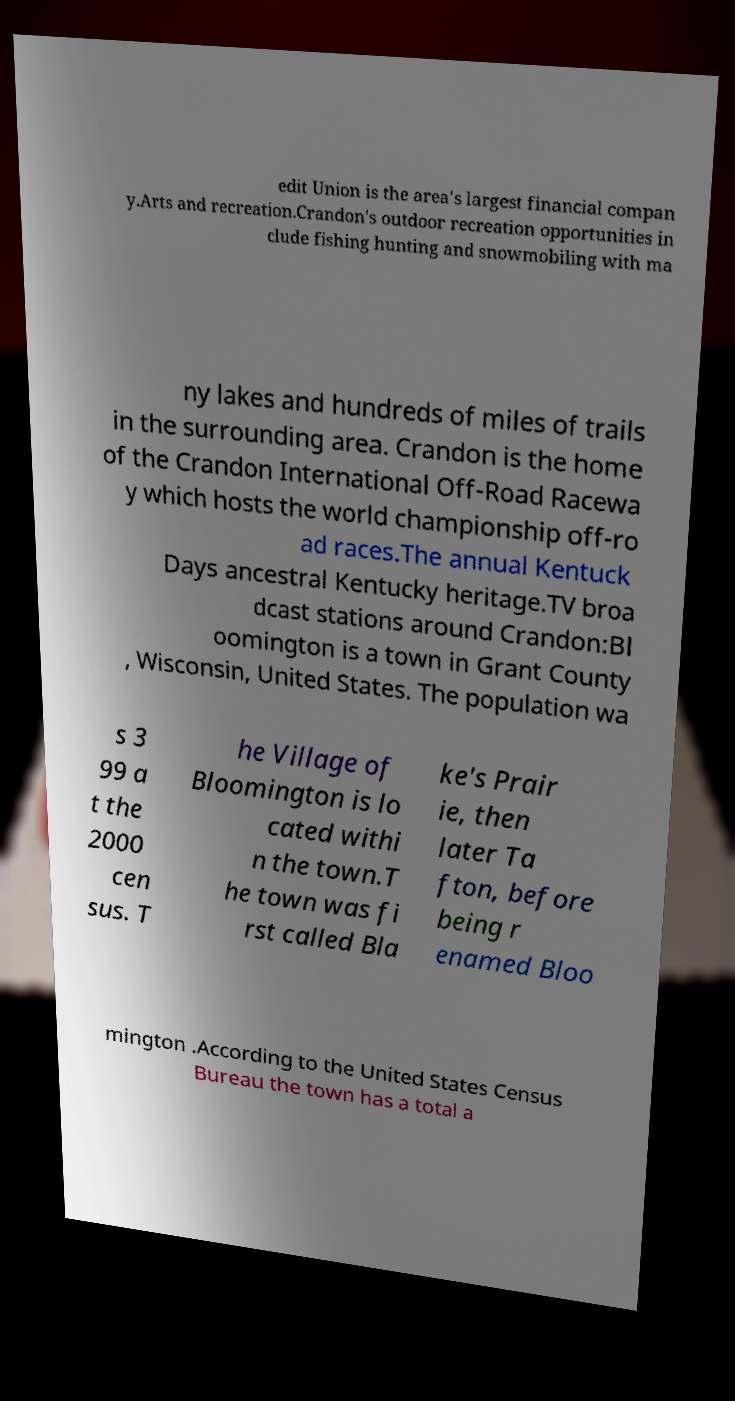Can you read and provide the text displayed in the image?This photo seems to have some interesting text. Can you extract and type it out for me? edit Union is the area's largest financial compan y.Arts and recreation.Crandon's outdoor recreation opportunities in clude fishing hunting and snowmobiling with ma ny lakes and hundreds of miles of trails in the surrounding area. Crandon is the home of the Crandon International Off-Road Racewa y which hosts the world championship off-ro ad races.The annual Kentuck Days ancestral Kentucky heritage.TV broa dcast stations around Crandon:Bl oomington is a town in Grant County , Wisconsin, United States. The population wa s 3 99 a t the 2000 cen sus. T he Village of Bloomington is lo cated withi n the town.T he town was fi rst called Bla ke's Prair ie, then later Ta fton, before being r enamed Bloo mington .According to the United States Census Bureau the town has a total a 